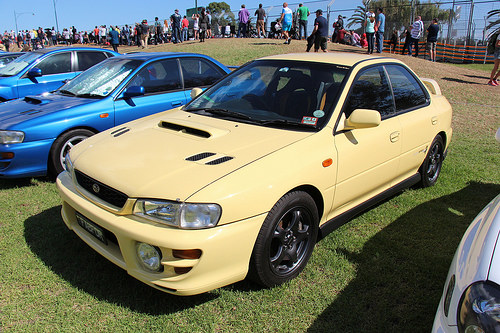<image>
Can you confirm if the yellow car is to the right of the blue car? Yes. From this viewpoint, the yellow car is positioned to the right side relative to the blue car. Is the car in front of the car? Yes. The car is positioned in front of the car, appearing closer to the camera viewpoint. 